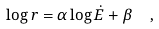<formula> <loc_0><loc_0><loc_500><loc_500>\log r = \alpha \log \dot { E } + \beta \ \ ,</formula> 